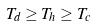<formula> <loc_0><loc_0><loc_500><loc_500>T _ { d } \geq T _ { h } \geq T _ { c }</formula> 